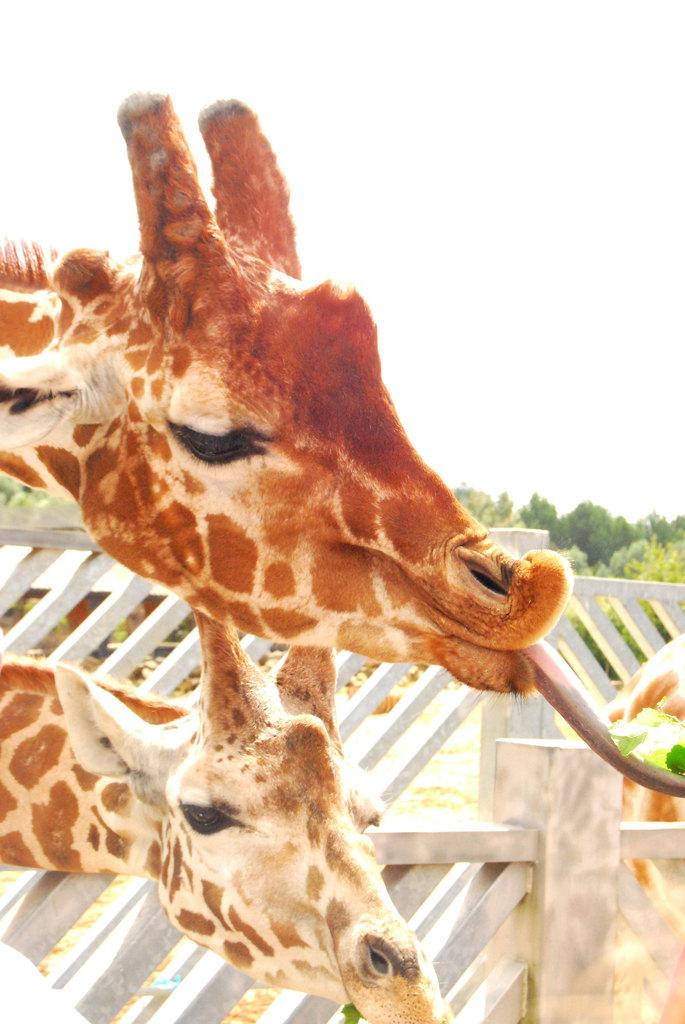How many giraffes are in the image? There are two giraffes in the image. What part of the giraffes can be seen in the image? The giraffes' heads are visible in the image. What is separating the giraffes from the background? The giraffes are in front of a fence. What is visible in the background of the image? The sky and trees are visible in the image. What type of soda is being advertised on the giraffes' necks in the image? There is no soda or advertisement present on the giraffes' necks in the image. Can you tell me how many birds are perched on the giraffes' heads in the image? There are no birds present on the giraffes' heads in the image. 